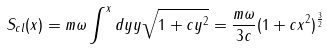Convert formula to latex. <formula><loc_0><loc_0><loc_500><loc_500>S _ { c l } ( x ) = m \omega \int ^ { x } d y y \sqrt { 1 + c y ^ { 2 } } = \frac { m \omega } { 3 c } ( 1 + c x ^ { 2 } ) ^ { \frac { 3 } { 2 } }</formula> 